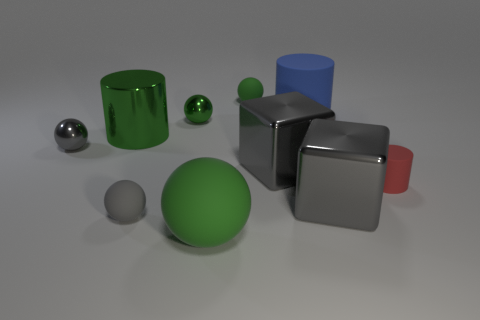Is the color of the big ball the same as the metal cylinder?
Your answer should be very brief. Yes. There is a matte cylinder that is in front of the blue cylinder that is behind the large metallic cylinder; are there any big matte objects in front of it?
Provide a succinct answer. Yes. How many other objects are the same color as the large ball?
Your answer should be compact. 3. What number of metal things are both in front of the big green metal thing and right of the tiny gray metal ball?
Give a very brief answer. 2. What shape is the red matte object?
Provide a succinct answer. Cylinder. What number of other things are there of the same material as the big blue object
Ensure brevity in your answer.  4. What color is the rubber cylinder behind the tiny green ball that is left of the large rubber object that is on the left side of the blue cylinder?
Your response must be concise. Blue. What material is the green sphere that is the same size as the blue cylinder?
Offer a terse response. Rubber. What number of objects are tiny gray spheres that are left of the small gray matte thing or small gray spheres?
Your answer should be compact. 2. Are there any green balls?
Your response must be concise. Yes. 